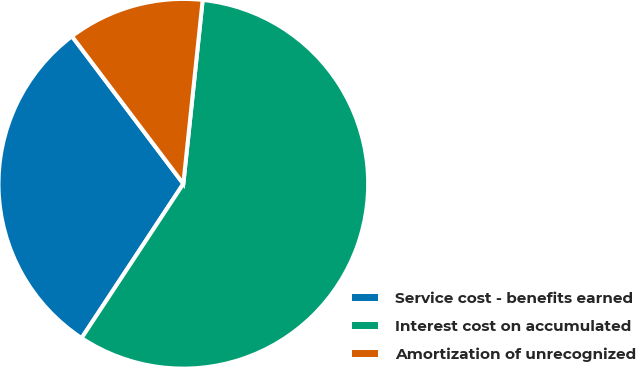<chart> <loc_0><loc_0><loc_500><loc_500><pie_chart><fcel>Service cost - benefits earned<fcel>Interest cost on accumulated<fcel>Amortization of unrecognized<nl><fcel>30.43%<fcel>57.61%<fcel>11.96%<nl></chart> 